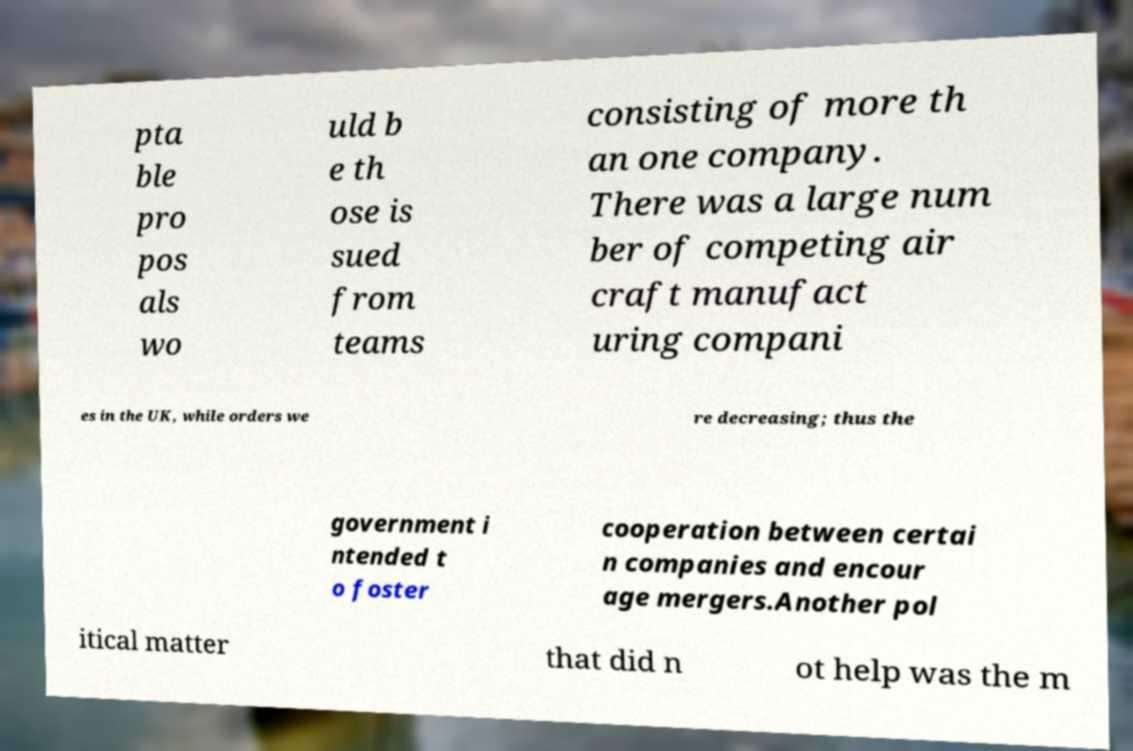Could you assist in decoding the text presented in this image and type it out clearly? pta ble pro pos als wo uld b e th ose is sued from teams consisting of more th an one company. There was a large num ber of competing air craft manufact uring compani es in the UK, while orders we re decreasing; thus the government i ntended t o foster cooperation between certai n companies and encour age mergers.Another pol itical matter that did n ot help was the m 